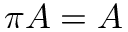Convert formula to latex. <formula><loc_0><loc_0><loc_500><loc_500>\pi A = A</formula> 